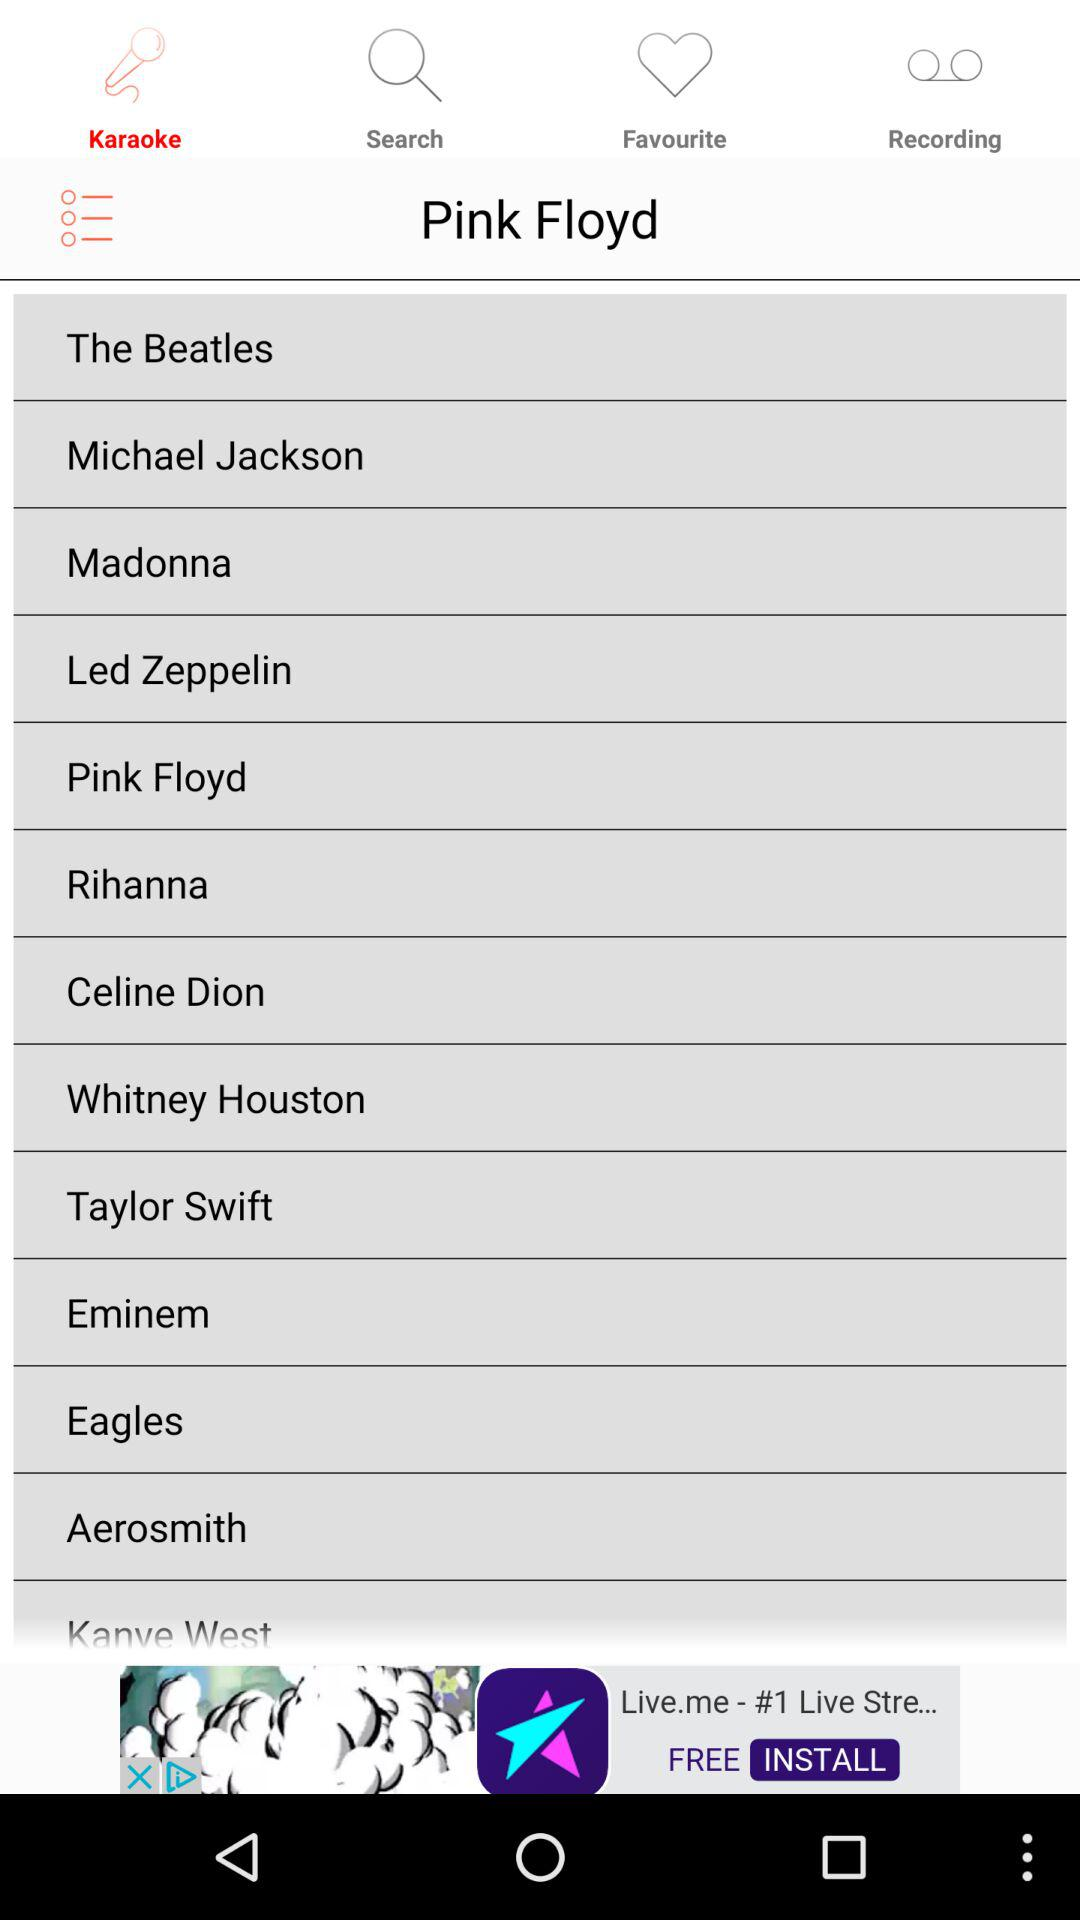Which tab is selected? The selected tab is "Karaoke". 